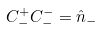<formula> <loc_0><loc_0><loc_500><loc_500>C _ { - } ^ { + } C _ { - } ^ { - } = \hat { n } _ { - }</formula> 